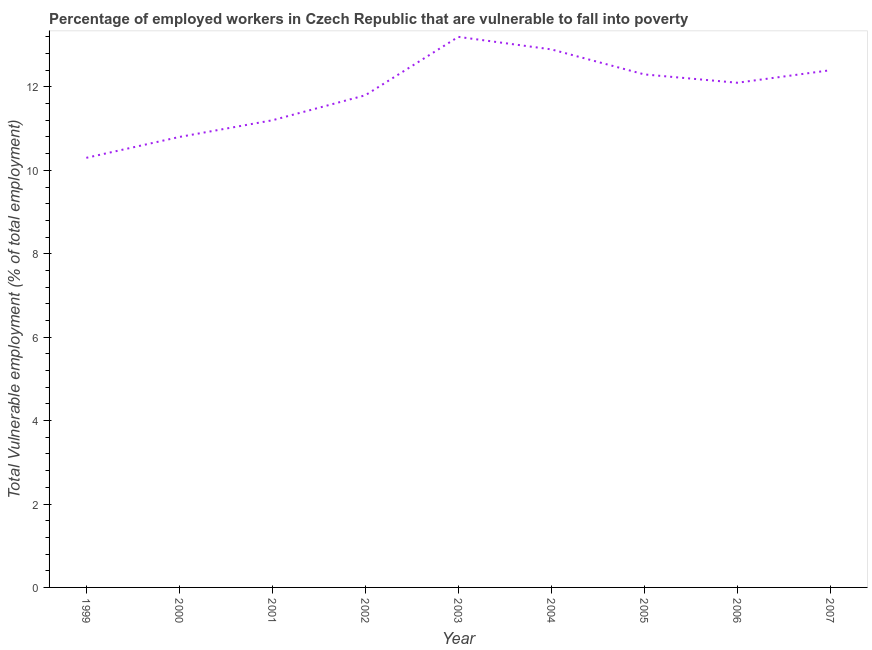What is the total vulnerable employment in 2005?
Your answer should be compact. 12.3. Across all years, what is the maximum total vulnerable employment?
Provide a short and direct response. 13.2. Across all years, what is the minimum total vulnerable employment?
Your answer should be compact. 10.3. In which year was the total vulnerable employment maximum?
Keep it short and to the point. 2003. In which year was the total vulnerable employment minimum?
Your answer should be compact. 1999. What is the sum of the total vulnerable employment?
Provide a succinct answer. 107. What is the difference between the total vulnerable employment in 2000 and 2006?
Your response must be concise. -1.3. What is the average total vulnerable employment per year?
Provide a succinct answer. 11.89. What is the median total vulnerable employment?
Provide a short and direct response. 12.1. What is the ratio of the total vulnerable employment in 2003 to that in 2006?
Provide a succinct answer. 1.09. Is the difference between the total vulnerable employment in 2000 and 2007 greater than the difference between any two years?
Give a very brief answer. No. What is the difference between the highest and the second highest total vulnerable employment?
Ensure brevity in your answer.  0.3. What is the difference between the highest and the lowest total vulnerable employment?
Offer a very short reply. 2.9. In how many years, is the total vulnerable employment greater than the average total vulnerable employment taken over all years?
Your answer should be very brief. 5. Does the total vulnerable employment monotonically increase over the years?
Provide a short and direct response. No. How many years are there in the graph?
Provide a succinct answer. 9. Are the values on the major ticks of Y-axis written in scientific E-notation?
Offer a very short reply. No. What is the title of the graph?
Your answer should be compact. Percentage of employed workers in Czech Republic that are vulnerable to fall into poverty. What is the label or title of the Y-axis?
Keep it short and to the point. Total Vulnerable employment (% of total employment). What is the Total Vulnerable employment (% of total employment) of 1999?
Ensure brevity in your answer.  10.3. What is the Total Vulnerable employment (% of total employment) in 2000?
Your response must be concise. 10.8. What is the Total Vulnerable employment (% of total employment) of 2001?
Your answer should be compact. 11.2. What is the Total Vulnerable employment (% of total employment) of 2002?
Keep it short and to the point. 11.8. What is the Total Vulnerable employment (% of total employment) in 2003?
Your answer should be compact. 13.2. What is the Total Vulnerable employment (% of total employment) of 2004?
Your response must be concise. 12.9. What is the Total Vulnerable employment (% of total employment) of 2005?
Ensure brevity in your answer.  12.3. What is the Total Vulnerable employment (% of total employment) in 2006?
Your answer should be very brief. 12.1. What is the Total Vulnerable employment (% of total employment) of 2007?
Give a very brief answer. 12.4. What is the difference between the Total Vulnerable employment (% of total employment) in 1999 and 2001?
Offer a terse response. -0.9. What is the difference between the Total Vulnerable employment (% of total employment) in 1999 and 2002?
Ensure brevity in your answer.  -1.5. What is the difference between the Total Vulnerable employment (% of total employment) in 1999 and 2003?
Your response must be concise. -2.9. What is the difference between the Total Vulnerable employment (% of total employment) in 1999 and 2005?
Provide a short and direct response. -2. What is the difference between the Total Vulnerable employment (% of total employment) in 1999 and 2006?
Your response must be concise. -1.8. What is the difference between the Total Vulnerable employment (% of total employment) in 2000 and 2006?
Provide a short and direct response. -1.3. What is the difference between the Total Vulnerable employment (% of total employment) in 2001 and 2002?
Offer a very short reply. -0.6. What is the difference between the Total Vulnerable employment (% of total employment) in 2001 and 2004?
Offer a very short reply. -1.7. What is the difference between the Total Vulnerable employment (% of total employment) in 2001 and 2005?
Give a very brief answer. -1.1. What is the difference between the Total Vulnerable employment (% of total employment) in 2001 and 2006?
Give a very brief answer. -0.9. What is the difference between the Total Vulnerable employment (% of total employment) in 2002 and 2004?
Your answer should be compact. -1.1. What is the difference between the Total Vulnerable employment (% of total employment) in 2002 and 2007?
Ensure brevity in your answer.  -0.6. What is the difference between the Total Vulnerable employment (% of total employment) in 2003 and 2004?
Offer a very short reply. 0.3. What is the difference between the Total Vulnerable employment (% of total employment) in 2004 and 2005?
Give a very brief answer. 0.6. What is the difference between the Total Vulnerable employment (% of total employment) in 2004 and 2006?
Your answer should be very brief. 0.8. What is the difference between the Total Vulnerable employment (% of total employment) in 2005 and 2006?
Your answer should be compact. 0.2. What is the ratio of the Total Vulnerable employment (% of total employment) in 1999 to that in 2000?
Offer a terse response. 0.95. What is the ratio of the Total Vulnerable employment (% of total employment) in 1999 to that in 2001?
Offer a very short reply. 0.92. What is the ratio of the Total Vulnerable employment (% of total employment) in 1999 to that in 2002?
Offer a very short reply. 0.87. What is the ratio of the Total Vulnerable employment (% of total employment) in 1999 to that in 2003?
Provide a succinct answer. 0.78. What is the ratio of the Total Vulnerable employment (% of total employment) in 1999 to that in 2004?
Your answer should be very brief. 0.8. What is the ratio of the Total Vulnerable employment (% of total employment) in 1999 to that in 2005?
Give a very brief answer. 0.84. What is the ratio of the Total Vulnerable employment (% of total employment) in 1999 to that in 2006?
Make the answer very short. 0.85. What is the ratio of the Total Vulnerable employment (% of total employment) in 1999 to that in 2007?
Keep it short and to the point. 0.83. What is the ratio of the Total Vulnerable employment (% of total employment) in 2000 to that in 2001?
Ensure brevity in your answer.  0.96. What is the ratio of the Total Vulnerable employment (% of total employment) in 2000 to that in 2002?
Make the answer very short. 0.92. What is the ratio of the Total Vulnerable employment (% of total employment) in 2000 to that in 2003?
Keep it short and to the point. 0.82. What is the ratio of the Total Vulnerable employment (% of total employment) in 2000 to that in 2004?
Ensure brevity in your answer.  0.84. What is the ratio of the Total Vulnerable employment (% of total employment) in 2000 to that in 2005?
Keep it short and to the point. 0.88. What is the ratio of the Total Vulnerable employment (% of total employment) in 2000 to that in 2006?
Your answer should be compact. 0.89. What is the ratio of the Total Vulnerable employment (% of total employment) in 2000 to that in 2007?
Give a very brief answer. 0.87. What is the ratio of the Total Vulnerable employment (% of total employment) in 2001 to that in 2002?
Your response must be concise. 0.95. What is the ratio of the Total Vulnerable employment (% of total employment) in 2001 to that in 2003?
Ensure brevity in your answer.  0.85. What is the ratio of the Total Vulnerable employment (% of total employment) in 2001 to that in 2004?
Your response must be concise. 0.87. What is the ratio of the Total Vulnerable employment (% of total employment) in 2001 to that in 2005?
Keep it short and to the point. 0.91. What is the ratio of the Total Vulnerable employment (% of total employment) in 2001 to that in 2006?
Offer a terse response. 0.93. What is the ratio of the Total Vulnerable employment (% of total employment) in 2001 to that in 2007?
Your answer should be compact. 0.9. What is the ratio of the Total Vulnerable employment (% of total employment) in 2002 to that in 2003?
Offer a very short reply. 0.89. What is the ratio of the Total Vulnerable employment (% of total employment) in 2002 to that in 2004?
Make the answer very short. 0.92. What is the ratio of the Total Vulnerable employment (% of total employment) in 2003 to that in 2004?
Your answer should be very brief. 1.02. What is the ratio of the Total Vulnerable employment (% of total employment) in 2003 to that in 2005?
Provide a succinct answer. 1.07. What is the ratio of the Total Vulnerable employment (% of total employment) in 2003 to that in 2006?
Keep it short and to the point. 1.09. What is the ratio of the Total Vulnerable employment (% of total employment) in 2003 to that in 2007?
Provide a succinct answer. 1.06. What is the ratio of the Total Vulnerable employment (% of total employment) in 2004 to that in 2005?
Keep it short and to the point. 1.05. What is the ratio of the Total Vulnerable employment (% of total employment) in 2004 to that in 2006?
Offer a terse response. 1.07. What is the ratio of the Total Vulnerable employment (% of total employment) in 2004 to that in 2007?
Your answer should be very brief. 1.04. What is the ratio of the Total Vulnerable employment (% of total employment) in 2005 to that in 2006?
Your answer should be compact. 1.02. 